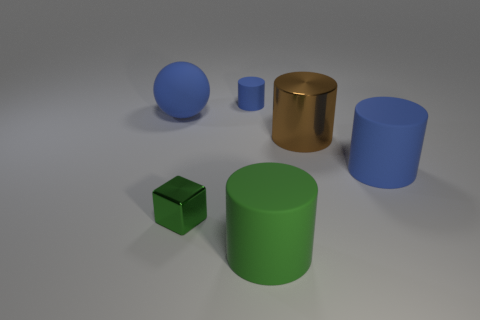Do the large sphere and the small rubber cylinder have the same color?
Offer a very short reply. Yes. There is a blue matte thing that is on the left side of the metal block; does it have the same shape as the brown object that is behind the small green shiny object?
Offer a terse response. No. What is the shape of the rubber thing that is the same color as the small cube?
Keep it short and to the point. Cylinder. Is there a tiny green ball made of the same material as the large green object?
Your answer should be very brief. No. How many rubber objects are blue spheres or large green cylinders?
Your response must be concise. 2. There is a big object behind the large brown metal cylinder that is left of the large blue cylinder; what shape is it?
Your answer should be compact. Sphere. Are there fewer big matte cylinders that are behind the green metallic object than cyan shiny balls?
Your answer should be very brief. No. The green rubber object is what shape?
Your answer should be compact. Cylinder. What size is the blue cylinder on the left side of the big green rubber cylinder?
Your response must be concise. Small. What color is the sphere that is the same size as the metal cylinder?
Your answer should be compact. Blue. 